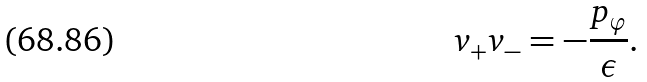Convert formula to latex. <formula><loc_0><loc_0><loc_500><loc_500>v _ { + } v _ { - } = - \frac { p _ { \varphi } } { \epsilon } .</formula> 